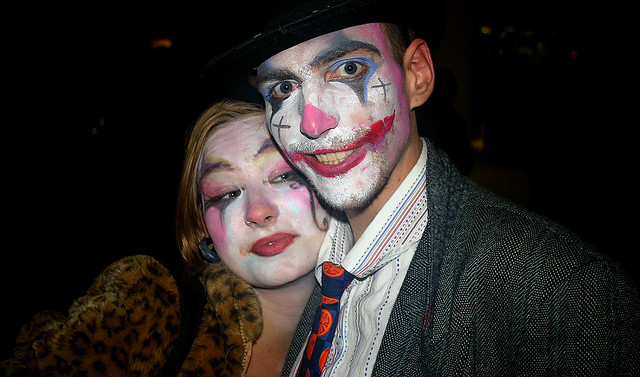<image>What is the black mark above the man's lip? I am unsure what the black mark above the man's lip is. It could be a mustache, paint, stubble, or even a cross shape. What is the black mark above the man's lip? It is ambiguous what the black mark above the man's lip is. It can be seen as a mustache, face paint, or stubble. 